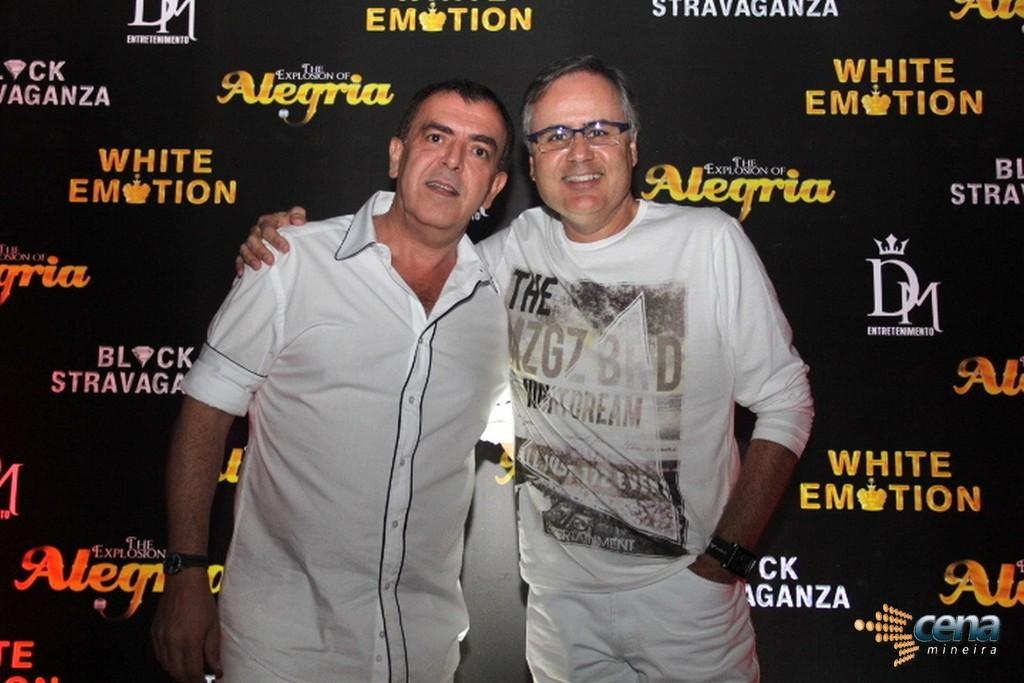<image>
Present a compact description of the photo's key features. Two men stand next to each other smiling for the camera behind a wall showing sponsors such as White Emotion. 